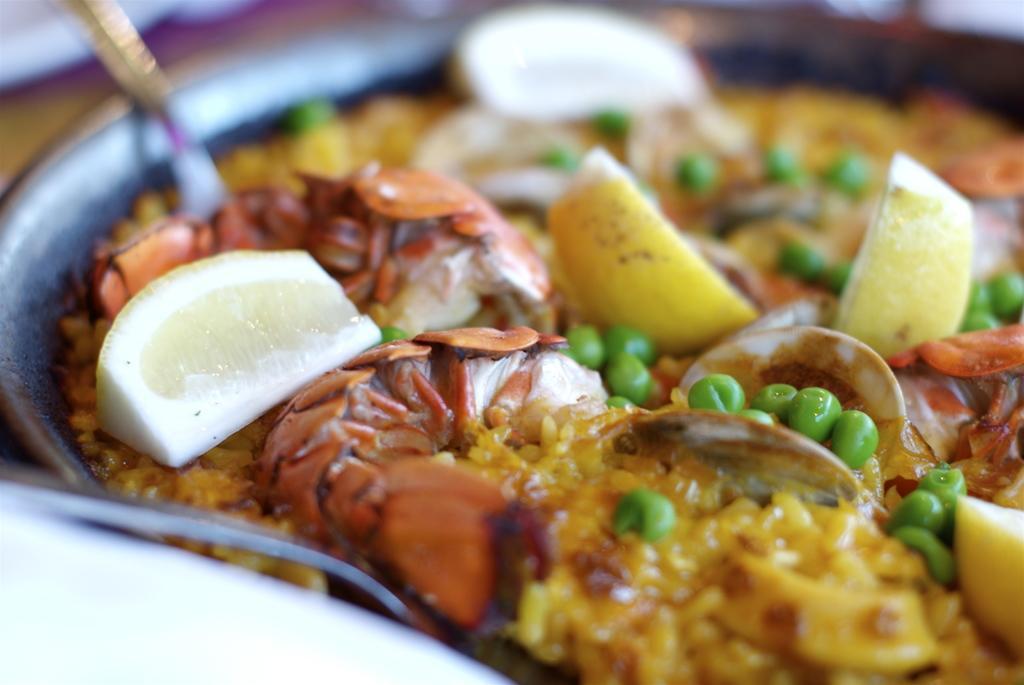Could you give a brief overview of what you see in this image? In this image we can see food item and a spoon in a plate and there are lemon slices on the food item and at the top and on the left side the image is blur but we can see objects. 